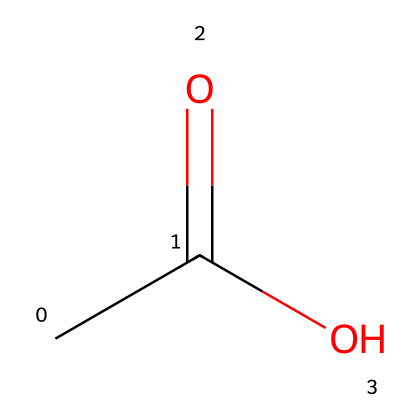What is the molecular formula of this chemical? The SMILES representation CC(=O)O indicates that there are two carbon atoms (C), four hydrogen atoms (H), and two oxygen atoms (O). Therefore, the molecular formula is C2H4O2.
Answer: C2H4O2 How many carbon atoms are present in this chemical? The SMILES representation shows two 'C' characters at the beginning, indicating that there are two carbon atoms in the structure.
Answer: 2 What type of functional group does this chemical contain? The presence of the -COOH group (indicated by the oxygen connected to a carbon with a double bond and also to a hydroxyl group) shows that it has a carboxylic acid functional group.
Answer: carboxylic acid Is this chemical considered a liquid at room temperature? Many carboxylic acids, particularly those with small carbon chains like this one (acetic acid), are liquids at room temperature. Therefore, it's reasonable to conclude this chemical is a liquid.
Answer: yes What is the main use of this chemical in eco-friendly cleaning solutions? Acetic acid (C2H4O2) is commonly used as a natural disinfectant and deodorizer, making it valuable in eco-friendly cleaning products.
Answer: disinfectant 